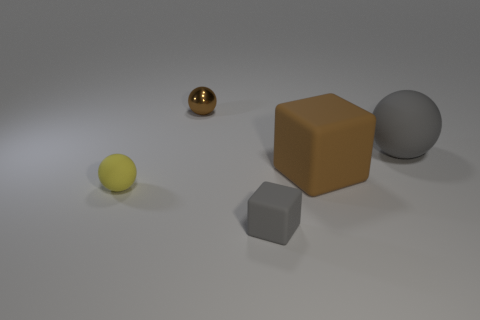What number of other objects are there of the same color as the small matte sphere?
Keep it short and to the point. 0. Does the metallic ball have the same color as the thing on the right side of the big brown thing?
Keep it short and to the point. No. What color is the other metallic object that is the same shape as the large gray object?
Ensure brevity in your answer.  Brown. Is the small cube made of the same material as the large thing that is on the right side of the brown rubber cube?
Your answer should be very brief. Yes. The metal thing is what color?
Offer a terse response. Brown. What color is the object behind the gray matte thing behind the small gray matte cube that is in front of the large brown object?
Keep it short and to the point. Brown. There is a large brown object; is it the same shape as the gray rubber thing in front of the small yellow rubber object?
Keep it short and to the point. Yes. There is a ball that is in front of the shiny ball and behind the tiny yellow matte sphere; what color is it?
Provide a succinct answer. Gray. Are there any red shiny things that have the same shape as the tiny gray rubber object?
Keep it short and to the point. No. Is the color of the tiny rubber cube the same as the big rubber sphere?
Ensure brevity in your answer.  Yes. 